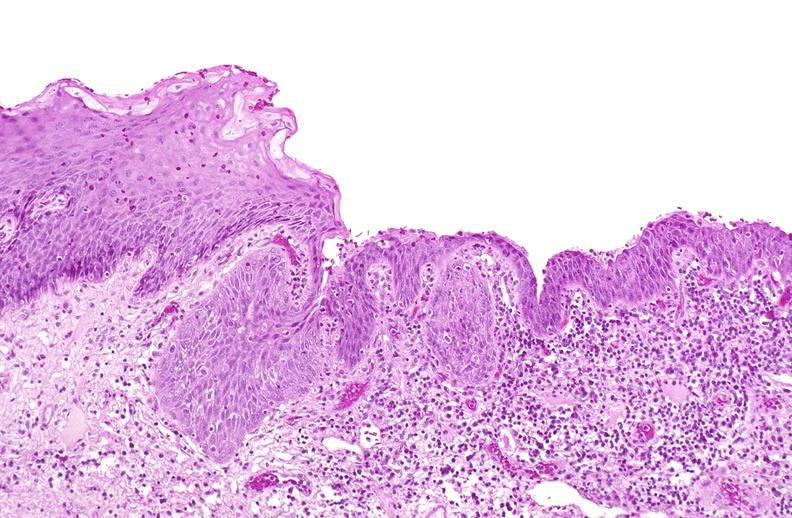why does this image show squamous metaplasia, renal pelvis?
Answer the question using a single word or phrase. Due to nephrolithiasis 